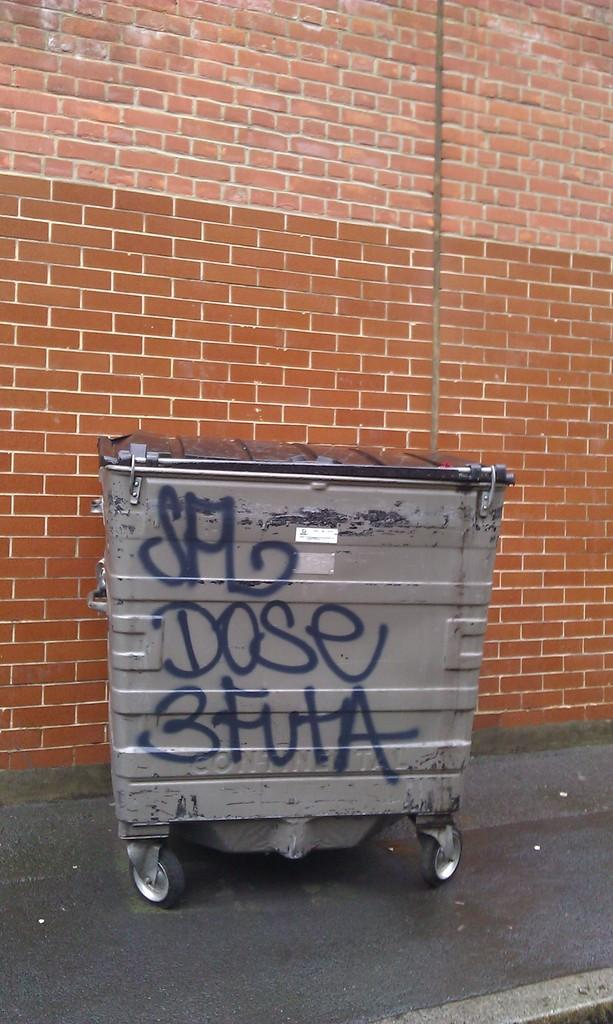<image>
Describe the image concisely. on a trash bin has been painted DOSE 3FUTA and another word 